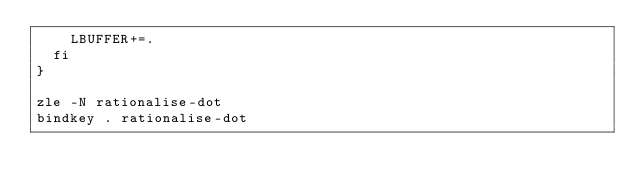Convert code to text. <code><loc_0><loc_0><loc_500><loc_500><_Bash_>    LBUFFER+=.
  fi
}

zle -N rationalise-dot
bindkey . rationalise-dot
</code> 